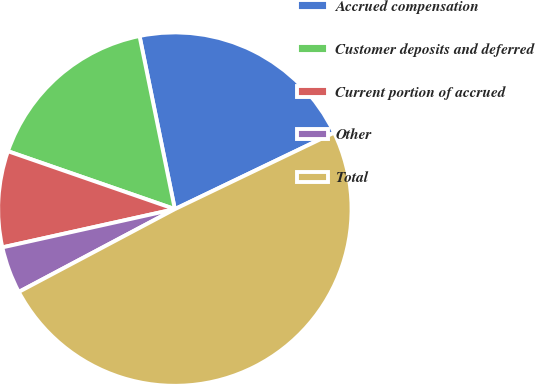Convert chart. <chart><loc_0><loc_0><loc_500><loc_500><pie_chart><fcel>Accrued compensation<fcel>Customer deposits and deferred<fcel>Current portion of accrued<fcel>Other<fcel>Total<nl><fcel>21.08%<fcel>16.48%<fcel>8.79%<fcel>4.29%<fcel>49.36%<nl></chart> 